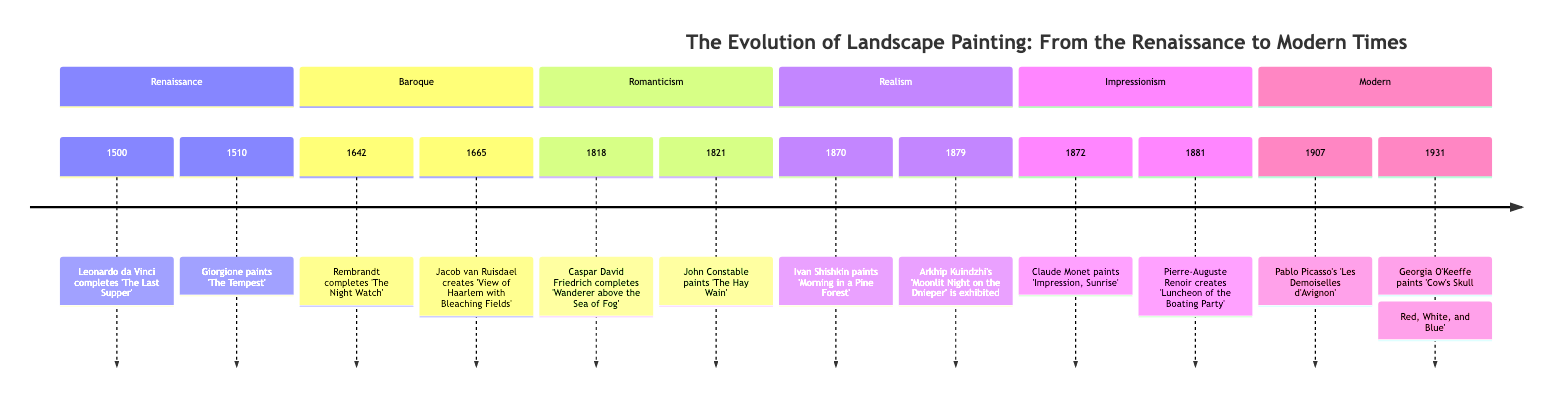What period is represented by the event "The Hay Wain"? The diagram shows "The Hay Wain" under the Romanticism section, indicating that it belongs to that particular period.
Answer: Romanticism How many key moments are there in the Impressionism period? By counting the events listed under the Impressionism section, there are two key moments.
Answer: 2 Who painted "Morning in a Pine Forest"? The diagram details that "Morning in a Pine Forest" is attributed to Ivan Shishkin, which is explicitly stated in the Realism section.
Answer: Ivan Shishkin Which artist's work marks the shift towards abstraction in 1907? The 1907 entry lists Pablo Picasso’s "Les Demoiselles d'Avignon," indicating that this event marks the shift towards abstraction.
Answer: Pablo Picasso What year did Arkhip Kuindzhi's "Moonlit Night on the Dnieper" get exhibited? The timeline specifies 1879 as the year when Arkhip Kuindzhi's "Moonlit Night on the Dnieper" was exhibited, which is explicitly mentioned under Realism.
Answer: 1879 What two significant works were created in 1818 and 1821? By examining the Romanticism section, we find that in 1818, "Wanderer above the Sea of Fog" was completed, and in 1821, "The Hay Wain" was painted, making these two significant works for those years.
Answer: "Wanderer above the Sea of Fog" and "The Hay Wain" Which period features the use of chiaroscuro in landscapes? The event "The Night Watch" by Rembrandt in 1642 highlights the Baroque period's dramatic use of chiaroscuro, as noted in the corresponding section.
Answer: Baroque What is a defining characteristic of Jacob van Ruisdael's 1665 painting? The timeline points out that Ruisdael's "View of Haarlem with Bleaching Fields" showcases the importance of the sky in landscape composition, which is a defining characteristic of this work.
Answer: Importance of sky How does Caspar David Friedrich's painting reflect human introspection? "Wanderer above the Sea of Fog" portrays human introspection against sublime nature, demonstrating a deep connection between man and the natural world, which is noted in the Romanticism section.
Answer: Human introspection against nature Which landscape artist focused on light and atmosphere in the 19th century? The diagram indicates that Claude Monet, with "Impression, Sunrise" in 1872, was crucial in giving rise to the Impressionist movement focused on light and atmosphere.
Answer: Claude Monet 